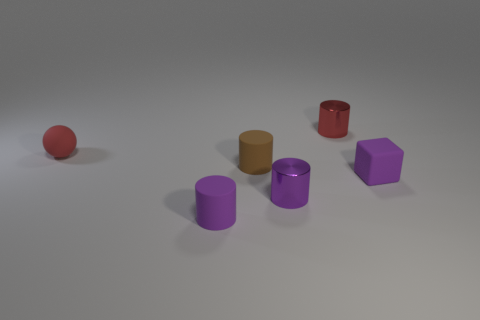Add 1 tiny red things. How many objects exist? 7 Subtract all blocks. How many objects are left? 5 Subtract 1 brown cylinders. How many objects are left? 5 Subtract all small red metallic cylinders. Subtract all cylinders. How many objects are left? 1 Add 4 cylinders. How many cylinders are left? 8 Add 3 matte blocks. How many matte blocks exist? 4 